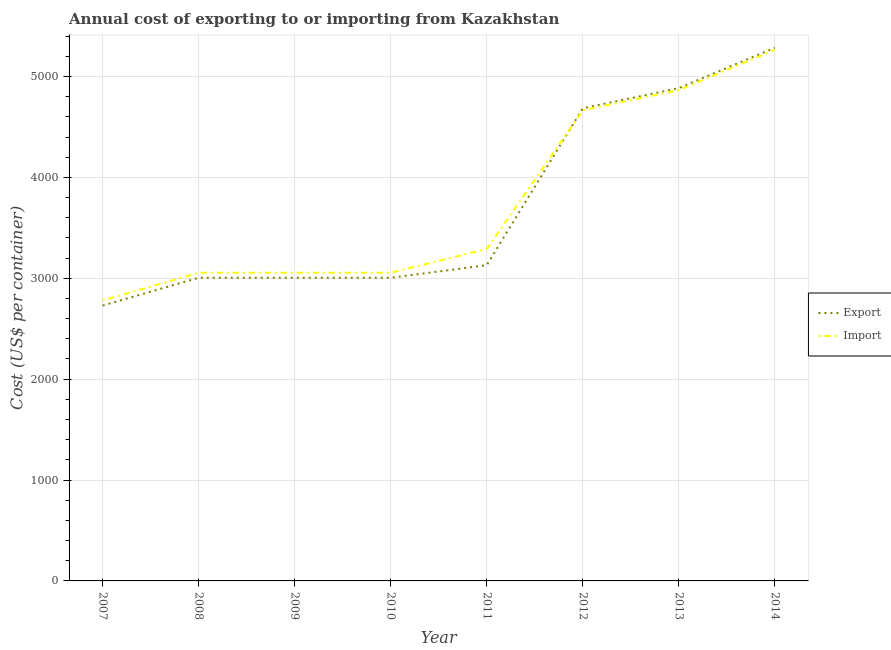How many different coloured lines are there?
Offer a terse response. 2. Does the line corresponding to import cost intersect with the line corresponding to export cost?
Provide a short and direct response. Yes. What is the export cost in 2013?
Your answer should be very brief. 4885. Across all years, what is the maximum import cost?
Give a very brief answer. 5265. Across all years, what is the minimum import cost?
Offer a very short reply. 2780. In which year was the export cost maximum?
Your answer should be very brief. 2014. What is the total import cost in the graph?
Keep it short and to the point. 3.00e+04. What is the difference between the export cost in 2008 and that in 2010?
Your response must be concise. 0. What is the difference between the import cost in 2007 and the export cost in 2010?
Offer a terse response. -225. What is the average import cost per year?
Ensure brevity in your answer.  3753.75. In the year 2010, what is the difference between the import cost and export cost?
Ensure brevity in your answer.  50. What is the ratio of the export cost in 2008 to that in 2012?
Your answer should be very brief. 0.64. Is the export cost in 2007 less than that in 2009?
Keep it short and to the point. Yes. Is the difference between the import cost in 2008 and 2011 greater than the difference between the export cost in 2008 and 2011?
Offer a very short reply. No. What is the difference between the highest and the lowest export cost?
Offer a very short reply. 2555. Does the import cost monotonically increase over the years?
Make the answer very short. No. Is the export cost strictly greater than the import cost over the years?
Keep it short and to the point. No. Is the export cost strictly less than the import cost over the years?
Give a very brief answer. No. How many years are there in the graph?
Keep it short and to the point. 8. What is the difference between two consecutive major ticks on the Y-axis?
Your response must be concise. 1000. How are the legend labels stacked?
Keep it short and to the point. Vertical. What is the title of the graph?
Provide a short and direct response. Annual cost of exporting to or importing from Kazakhstan. Does "Subsidies" appear as one of the legend labels in the graph?
Your answer should be very brief. No. What is the label or title of the X-axis?
Provide a succinct answer. Year. What is the label or title of the Y-axis?
Your answer should be very brief. Cost (US$ per container). What is the Cost (US$ per container) of Export in 2007?
Make the answer very short. 2730. What is the Cost (US$ per container) in Import in 2007?
Your answer should be compact. 2780. What is the Cost (US$ per container) in Export in 2008?
Keep it short and to the point. 3005. What is the Cost (US$ per container) of Import in 2008?
Keep it short and to the point. 3055. What is the Cost (US$ per container) of Export in 2009?
Make the answer very short. 3005. What is the Cost (US$ per container) in Import in 2009?
Offer a terse response. 3055. What is the Cost (US$ per container) in Export in 2010?
Offer a terse response. 3005. What is the Cost (US$ per container) in Import in 2010?
Give a very brief answer. 3055. What is the Cost (US$ per container) of Export in 2011?
Provide a short and direct response. 3130. What is the Cost (US$ per container) of Import in 2011?
Ensure brevity in your answer.  3290. What is the Cost (US$ per container) of Export in 2012?
Your response must be concise. 4685. What is the Cost (US$ per container) in Import in 2012?
Your answer should be compact. 4665. What is the Cost (US$ per container) of Export in 2013?
Your answer should be compact. 4885. What is the Cost (US$ per container) in Import in 2013?
Provide a succinct answer. 4865. What is the Cost (US$ per container) in Export in 2014?
Provide a short and direct response. 5285. What is the Cost (US$ per container) of Import in 2014?
Ensure brevity in your answer.  5265. Across all years, what is the maximum Cost (US$ per container) in Export?
Your answer should be very brief. 5285. Across all years, what is the maximum Cost (US$ per container) of Import?
Your answer should be compact. 5265. Across all years, what is the minimum Cost (US$ per container) of Export?
Keep it short and to the point. 2730. Across all years, what is the minimum Cost (US$ per container) in Import?
Your answer should be very brief. 2780. What is the total Cost (US$ per container) in Export in the graph?
Offer a very short reply. 2.97e+04. What is the total Cost (US$ per container) of Import in the graph?
Your answer should be very brief. 3.00e+04. What is the difference between the Cost (US$ per container) of Export in 2007 and that in 2008?
Your response must be concise. -275. What is the difference between the Cost (US$ per container) of Import in 2007 and that in 2008?
Your answer should be very brief. -275. What is the difference between the Cost (US$ per container) in Export in 2007 and that in 2009?
Your answer should be very brief. -275. What is the difference between the Cost (US$ per container) in Import in 2007 and that in 2009?
Your response must be concise. -275. What is the difference between the Cost (US$ per container) in Export in 2007 and that in 2010?
Provide a succinct answer. -275. What is the difference between the Cost (US$ per container) of Import in 2007 and that in 2010?
Make the answer very short. -275. What is the difference between the Cost (US$ per container) in Export in 2007 and that in 2011?
Provide a short and direct response. -400. What is the difference between the Cost (US$ per container) of Import in 2007 and that in 2011?
Your answer should be compact. -510. What is the difference between the Cost (US$ per container) of Export in 2007 and that in 2012?
Offer a very short reply. -1955. What is the difference between the Cost (US$ per container) of Import in 2007 and that in 2012?
Your answer should be very brief. -1885. What is the difference between the Cost (US$ per container) of Export in 2007 and that in 2013?
Make the answer very short. -2155. What is the difference between the Cost (US$ per container) of Import in 2007 and that in 2013?
Give a very brief answer. -2085. What is the difference between the Cost (US$ per container) in Export in 2007 and that in 2014?
Provide a succinct answer. -2555. What is the difference between the Cost (US$ per container) of Import in 2007 and that in 2014?
Your answer should be very brief. -2485. What is the difference between the Cost (US$ per container) of Export in 2008 and that in 2009?
Provide a succinct answer. 0. What is the difference between the Cost (US$ per container) in Import in 2008 and that in 2009?
Your response must be concise. 0. What is the difference between the Cost (US$ per container) of Import in 2008 and that in 2010?
Ensure brevity in your answer.  0. What is the difference between the Cost (US$ per container) in Export in 2008 and that in 2011?
Ensure brevity in your answer.  -125. What is the difference between the Cost (US$ per container) of Import in 2008 and that in 2011?
Your answer should be very brief. -235. What is the difference between the Cost (US$ per container) in Export in 2008 and that in 2012?
Keep it short and to the point. -1680. What is the difference between the Cost (US$ per container) in Import in 2008 and that in 2012?
Your answer should be compact. -1610. What is the difference between the Cost (US$ per container) of Export in 2008 and that in 2013?
Provide a succinct answer. -1880. What is the difference between the Cost (US$ per container) in Import in 2008 and that in 2013?
Keep it short and to the point. -1810. What is the difference between the Cost (US$ per container) in Export in 2008 and that in 2014?
Provide a short and direct response. -2280. What is the difference between the Cost (US$ per container) of Import in 2008 and that in 2014?
Make the answer very short. -2210. What is the difference between the Cost (US$ per container) of Export in 2009 and that in 2010?
Make the answer very short. 0. What is the difference between the Cost (US$ per container) of Import in 2009 and that in 2010?
Keep it short and to the point. 0. What is the difference between the Cost (US$ per container) in Export in 2009 and that in 2011?
Keep it short and to the point. -125. What is the difference between the Cost (US$ per container) in Import in 2009 and that in 2011?
Your answer should be compact. -235. What is the difference between the Cost (US$ per container) in Export in 2009 and that in 2012?
Offer a terse response. -1680. What is the difference between the Cost (US$ per container) in Import in 2009 and that in 2012?
Make the answer very short. -1610. What is the difference between the Cost (US$ per container) of Export in 2009 and that in 2013?
Your response must be concise. -1880. What is the difference between the Cost (US$ per container) of Import in 2009 and that in 2013?
Your response must be concise. -1810. What is the difference between the Cost (US$ per container) of Export in 2009 and that in 2014?
Your response must be concise. -2280. What is the difference between the Cost (US$ per container) in Import in 2009 and that in 2014?
Your response must be concise. -2210. What is the difference between the Cost (US$ per container) of Export in 2010 and that in 2011?
Keep it short and to the point. -125. What is the difference between the Cost (US$ per container) of Import in 2010 and that in 2011?
Your answer should be compact. -235. What is the difference between the Cost (US$ per container) of Export in 2010 and that in 2012?
Your answer should be very brief. -1680. What is the difference between the Cost (US$ per container) in Import in 2010 and that in 2012?
Provide a short and direct response. -1610. What is the difference between the Cost (US$ per container) of Export in 2010 and that in 2013?
Keep it short and to the point. -1880. What is the difference between the Cost (US$ per container) in Import in 2010 and that in 2013?
Make the answer very short. -1810. What is the difference between the Cost (US$ per container) of Export in 2010 and that in 2014?
Give a very brief answer. -2280. What is the difference between the Cost (US$ per container) in Import in 2010 and that in 2014?
Your response must be concise. -2210. What is the difference between the Cost (US$ per container) of Export in 2011 and that in 2012?
Provide a short and direct response. -1555. What is the difference between the Cost (US$ per container) of Import in 2011 and that in 2012?
Give a very brief answer. -1375. What is the difference between the Cost (US$ per container) of Export in 2011 and that in 2013?
Keep it short and to the point. -1755. What is the difference between the Cost (US$ per container) of Import in 2011 and that in 2013?
Provide a short and direct response. -1575. What is the difference between the Cost (US$ per container) in Export in 2011 and that in 2014?
Your answer should be compact. -2155. What is the difference between the Cost (US$ per container) in Import in 2011 and that in 2014?
Give a very brief answer. -1975. What is the difference between the Cost (US$ per container) of Export in 2012 and that in 2013?
Offer a very short reply. -200. What is the difference between the Cost (US$ per container) of Import in 2012 and that in 2013?
Offer a terse response. -200. What is the difference between the Cost (US$ per container) in Export in 2012 and that in 2014?
Provide a succinct answer. -600. What is the difference between the Cost (US$ per container) of Import in 2012 and that in 2014?
Provide a short and direct response. -600. What is the difference between the Cost (US$ per container) of Export in 2013 and that in 2014?
Keep it short and to the point. -400. What is the difference between the Cost (US$ per container) of Import in 2013 and that in 2014?
Your answer should be compact. -400. What is the difference between the Cost (US$ per container) in Export in 2007 and the Cost (US$ per container) in Import in 2008?
Your answer should be compact. -325. What is the difference between the Cost (US$ per container) in Export in 2007 and the Cost (US$ per container) in Import in 2009?
Offer a very short reply. -325. What is the difference between the Cost (US$ per container) of Export in 2007 and the Cost (US$ per container) of Import in 2010?
Your response must be concise. -325. What is the difference between the Cost (US$ per container) of Export in 2007 and the Cost (US$ per container) of Import in 2011?
Make the answer very short. -560. What is the difference between the Cost (US$ per container) in Export in 2007 and the Cost (US$ per container) in Import in 2012?
Keep it short and to the point. -1935. What is the difference between the Cost (US$ per container) in Export in 2007 and the Cost (US$ per container) in Import in 2013?
Your answer should be very brief. -2135. What is the difference between the Cost (US$ per container) in Export in 2007 and the Cost (US$ per container) in Import in 2014?
Offer a terse response. -2535. What is the difference between the Cost (US$ per container) in Export in 2008 and the Cost (US$ per container) in Import in 2009?
Offer a terse response. -50. What is the difference between the Cost (US$ per container) of Export in 2008 and the Cost (US$ per container) of Import in 2010?
Provide a short and direct response. -50. What is the difference between the Cost (US$ per container) of Export in 2008 and the Cost (US$ per container) of Import in 2011?
Your answer should be very brief. -285. What is the difference between the Cost (US$ per container) in Export in 2008 and the Cost (US$ per container) in Import in 2012?
Make the answer very short. -1660. What is the difference between the Cost (US$ per container) of Export in 2008 and the Cost (US$ per container) of Import in 2013?
Your answer should be very brief. -1860. What is the difference between the Cost (US$ per container) in Export in 2008 and the Cost (US$ per container) in Import in 2014?
Ensure brevity in your answer.  -2260. What is the difference between the Cost (US$ per container) of Export in 2009 and the Cost (US$ per container) of Import in 2011?
Make the answer very short. -285. What is the difference between the Cost (US$ per container) in Export in 2009 and the Cost (US$ per container) in Import in 2012?
Offer a terse response. -1660. What is the difference between the Cost (US$ per container) of Export in 2009 and the Cost (US$ per container) of Import in 2013?
Provide a short and direct response. -1860. What is the difference between the Cost (US$ per container) of Export in 2009 and the Cost (US$ per container) of Import in 2014?
Your response must be concise. -2260. What is the difference between the Cost (US$ per container) in Export in 2010 and the Cost (US$ per container) in Import in 2011?
Your answer should be compact. -285. What is the difference between the Cost (US$ per container) in Export in 2010 and the Cost (US$ per container) in Import in 2012?
Provide a succinct answer. -1660. What is the difference between the Cost (US$ per container) in Export in 2010 and the Cost (US$ per container) in Import in 2013?
Your answer should be compact. -1860. What is the difference between the Cost (US$ per container) in Export in 2010 and the Cost (US$ per container) in Import in 2014?
Give a very brief answer. -2260. What is the difference between the Cost (US$ per container) of Export in 2011 and the Cost (US$ per container) of Import in 2012?
Make the answer very short. -1535. What is the difference between the Cost (US$ per container) of Export in 2011 and the Cost (US$ per container) of Import in 2013?
Offer a terse response. -1735. What is the difference between the Cost (US$ per container) in Export in 2011 and the Cost (US$ per container) in Import in 2014?
Offer a terse response. -2135. What is the difference between the Cost (US$ per container) of Export in 2012 and the Cost (US$ per container) of Import in 2013?
Give a very brief answer. -180. What is the difference between the Cost (US$ per container) of Export in 2012 and the Cost (US$ per container) of Import in 2014?
Your answer should be compact. -580. What is the difference between the Cost (US$ per container) in Export in 2013 and the Cost (US$ per container) in Import in 2014?
Offer a terse response. -380. What is the average Cost (US$ per container) in Export per year?
Give a very brief answer. 3716.25. What is the average Cost (US$ per container) in Import per year?
Your answer should be compact. 3753.75. In the year 2008, what is the difference between the Cost (US$ per container) in Export and Cost (US$ per container) in Import?
Offer a very short reply. -50. In the year 2009, what is the difference between the Cost (US$ per container) of Export and Cost (US$ per container) of Import?
Your answer should be very brief. -50. In the year 2010, what is the difference between the Cost (US$ per container) of Export and Cost (US$ per container) of Import?
Give a very brief answer. -50. In the year 2011, what is the difference between the Cost (US$ per container) in Export and Cost (US$ per container) in Import?
Give a very brief answer. -160. In the year 2012, what is the difference between the Cost (US$ per container) of Export and Cost (US$ per container) of Import?
Offer a terse response. 20. In the year 2013, what is the difference between the Cost (US$ per container) in Export and Cost (US$ per container) in Import?
Keep it short and to the point. 20. In the year 2014, what is the difference between the Cost (US$ per container) in Export and Cost (US$ per container) in Import?
Make the answer very short. 20. What is the ratio of the Cost (US$ per container) in Export in 2007 to that in 2008?
Keep it short and to the point. 0.91. What is the ratio of the Cost (US$ per container) in Import in 2007 to that in 2008?
Your response must be concise. 0.91. What is the ratio of the Cost (US$ per container) in Export in 2007 to that in 2009?
Keep it short and to the point. 0.91. What is the ratio of the Cost (US$ per container) in Import in 2007 to that in 2009?
Give a very brief answer. 0.91. What is the ratio of the Cost (US$ per container) of Export in 2007 to that in 2010?
Provide a short and direct response. 0.91. What is the ratio of the Cost (US$ per container) of Import in 2007 to that in 2010?
Offer a very short reply. 0.91. What is the ratio of the Cost (US$ per container) in Export in 2007 to that in 2011?
Keep it short and to the point. 0.87. What is the ratio of the Cost (US$ per container) in Import in 2007 to that in 2011?
Make the answer very short. 0.84. What is the ratio of the Cost (US$ per container) of Export in 2007 to that in 2012?
Your answer should be compact. 0.58. What is the ratio of the Cost (US$ per container) in Import in 2007 to that in 2012?
Your answer should be compact. 0.6. What is the ratio of the Cost (US$ per container) of Export in 2007 to that in 2013?
Offer a very short reply. 0.56. What is the ratio of the Cost (US$ per container) in Export in 2007 to that in 2014?
Give a very brief answer. 0.52. What is the ratio of the Cost (US$ per container) of Import in 2007 to that in 2014?
Make the answer very short. 0.53. What is the ratio of the Cost (US$ per container) of Export in 2008 to that in 2009?
Give a very brief answer. 1. What is the ratio of the Cost (US$ per container) of Import in 2008 to that in 2009?
Provide a succinct answer. 1. What is the ratio of the Cost (US$ per container) of Export in 2008 to that in 2010?
Offer a terse response. 1. What is the ratio of the Cost (US$ per container) of Import in 2008 to that in 2010?
Offer a very short reply. 1. What is the ratio of the Cost (US$ per container) in Export in 2008 to that in 2011?
Provide a short and direct response. 0.96. What is the ratio of the Cost (US$ per container) in Export in 2008 to that in 2012?
Give a very brief answer. 0.64. What is the ratio of the Cost (US$ per container) of Import in 2008 to that in 2012?
Ensure brevity in your answer.  0.65. What is the ratio of the Cost (US$ per container) in Export in 2008 to that in 2013?
Your answer should be compact. 0.62. What is the ratio of the Cost (US$ per container) of Import in 2008 to that in 2013?
Your response must be concise. 0.63. What is the ratio of the Cost (US$ per container) in Export in 2008 to that in 2014?
Provide a short and direct response. 0.57. What is the ratio of the Cost (US$ per container) of Import in 2008 to that in 2014?
Offer a very short reply. 0.58. What is the ratio of the Cost (US$ per container) of Export in 2009 to that in 2010?
Make the answer very short. 1. What is the ratio of the Cost (US$ per container) of Export in 2009 to that in 2011?
Your answer should be compact. 0.96. What is the ratio of the Cost (US$ per container) in Import in 2009 to that in 2011?
Your response must be concise. 0.93. What is the ratio of the Cost (US$ per container) of Export in 2009 to that in 2012?
Your response must be concise. 0.64. What is the ratio of the Cost (US$ per container) in Import in 2009 to that in 2012?
Give a very brief answer. 0.65. What is the ratio of the Cost (US$ per container) in Export in 2009 to that in 2013?
Provide a succinct answer. 0.62. What is the ratio of the Cost (US$ per container) in Import in 2009 to that in 2013?
Offer a terse response. 0.63. What is the ratio of the Cost (US$ per container) in Export in 2009 to that in 2014?
Provide a succinct answer. 0.57. What is the ratio of the Cost (US$ per container) of Import in 2009 to that in 2014?
Offer a terse response. 0.58. What is the ratio of the Cost (US$ per container) of Export in 2010 to that in 2011?
Offer a very short reply. 0.96. What is the ratio of the Cost (US$ per container) in Import in 2010 to that in 2011?
Provide a succinct answer. 0.93. What is the ratio of the Cost (US$ per container) in Export in 2010 to that in 2012?
Your answer should be very brief. 0.64. What is the ratio of the Cost (US$ per container) in Import in 2010 to that in 2012?
Provide a short and direct response. 0.65. What is the ratio of the Cost (US$ per container) of Export in 2010 to that in 2013?
Offer a very short reply. 0.62. What is the ratio of the Cost (US$ per container) in Import in 2010 to that in 2013?
Offer a very short reply. 0.63. What is the ratio of the Cost (US$ per container) of Export in 2010 to that in 2014?
Your answer should be very brief. 0.57. What is the ratio of the Cost (US$ per container) of Import in 2010 to that in 2014?
Keep it short and to the point. 0.58. What is the ratio of the Cost (US$ per container) in Export in 2011 to that in 2012?
Your answer should be compact. 0.67. What is the ratio of the Cost (US$ per container) in Import in 2011 to that in 2012?
Provide a short and direct response. 0.71. What is the ratio of the Cost (US$ per container) of Export in 2011 to that in 2013?
Your answer should be compact. 0.64. What is the ratio of the Cost (US$ per container) in Import in 2011 to that in 2013?
Your answer should be very brief. 0.68. What is the ratio of the Cost (US$ per container) of Export in 2011 to that in 2014?
Provide a short and direct response. 0.59. What is the ratio of the Cost (US$ per container) of Import in 2011 to that in 2014?
Your answer should be very brief. 0.62. What is the ratio of the Cost (US$ per container) of Export in 2012 to that in 2013?
Ensure brevity in your answer.  0.96. What is the ratio of the Cost (US$ per container) in Import in 2012 to that in 2013?
Give a very brief answer. 0.96. What is the ratio of the Cost (US$ per container) in Export in 2012 to that in 2014?
Keep it short and to the point. 0.89. What is the ratio of the Cost (US$ per container) of Import in 2012 to that in 2014?
Offer a very short reply. 0.89. What is the ratio of the Cost (US$ per container) of Export in 2013 to that in 2014?
Give a very brief answer. 0.92. What is the ratio of the Cost (US$ per container) in Import in 2013 to that in 2014?
Your answer should be compact. 0.92. What is the difference between the highest and the lowest Cost (US$ per container) of Export?
Your response must be concise. 2555. What is the difference between the highest and the lowest Cost (US$ per container) in Import?
Your answer should be very brief. 2485. 